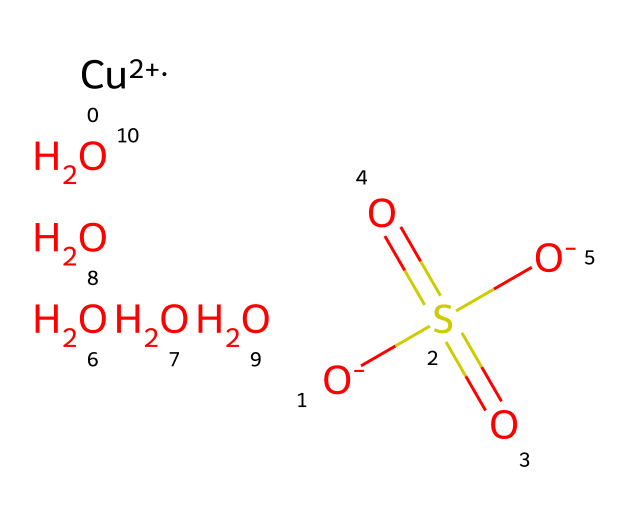What is the central metal atom in copper sulfate? The chemical contains copper, which is represented by "Cu" in the SMILES structure. It indicates that copper serves as the central metal atom.
Answer: copper How many oxygen atoms are present in copper sulfate? The SMILES representation shows "O" occurring five times, indicating there are five oxygen atoms bonded in different arrangements to the molecule.
Answer: five What is the charge of the copper ion in this compound? In the SMILES notation, the copper is designated as "[Cu+2]", which denotes a +2 oxidation state, meaning the copper ion has a charge of +2.
Answer: +2 What functional group is represented by "S(=O)(=O)" in the structure? The notation "S(=O)(=O)" indicates that sulfur is bonded to three oxygen atoms, two of which are double-bonded, characterizing the sulfate functional group.
Answer: sulfate Which part of this chemical is responsible for its solubility in water? The presence of sulfate and the high charge of the copper ion facilitate the ionic interactions with water, enhancing solubility, which is a property of ionic compounds.
Answer: ionic interactions What is the total number of sulfur and oxygen atoms combined in this chemical? From the SMILES, there is one sulfur atom and five oxygen atoms. Adding these gives a total of six atoms combined.
Answer: six What type of compound is copper sulfate considered? Copper sulfate is classified as a salt, specifically an inorganic salt, derived from the neutralization of sulfuric acid by copper.
Answer: salt 